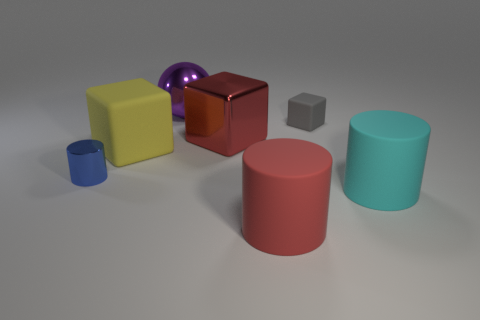Subtract all small rubber blocks. How many blocks are left? 2 Add 2 big metallic cubes. How many objects exist? 9 Subtract all cyan cylinders. How many cylinders are left? 2 Subtract 1 cubes. How many cubes are left? 2 Subtract all blocks. How many objects are left? 4 Subtract all brown blocks. Subtract all blue spheres. How many blocks are left? 3 Add 1 small metal things. How many small metal things exist? 2 Subtract 0 gray balls. How many objects are left? 7 Subtract all small objects. Subtract all gray rubber blocks. How many objects are left? 4 Add 7 tiny blue things. How many tiny blue things are left? 8 